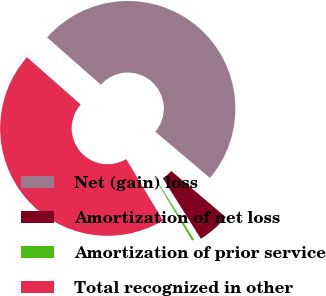<chart> <loc_0><loc_0><loc_500><loc_500><pie_chart><fcel>Net (gain) loss<fcel>Amortization of net loss<fcel>Amortization of prior service<fcel>Total recognized in other<nl><fcel>49.68%<fcel>4.91%<fcel>0.32%<fcel>45.09%<nl></chart> 